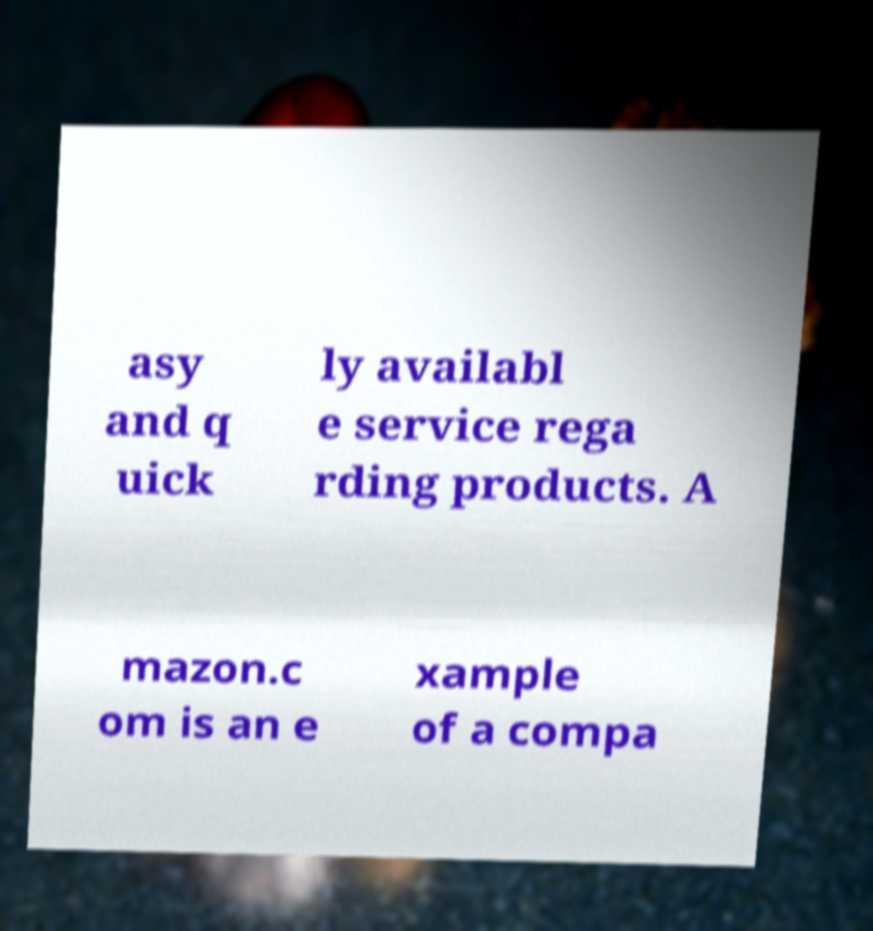What messages or text are displayed in this image? I need them in a readable, typed format. asy and q uick ly availabl e service rega rding products. A mazon.c om is an e xample of a compa 